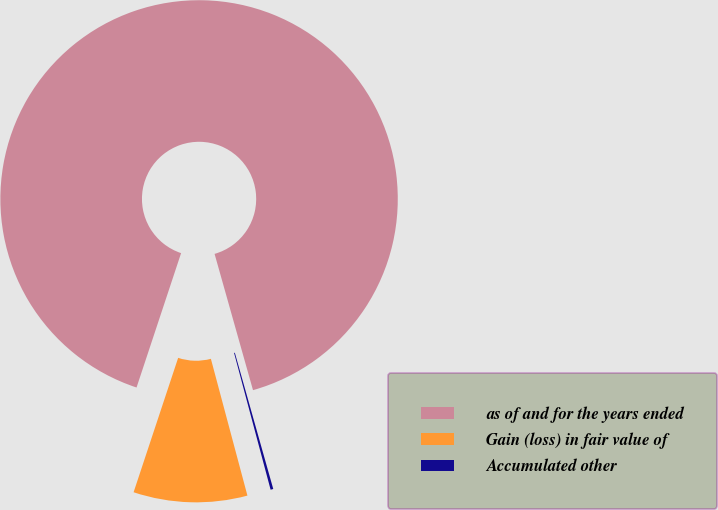Convert chart. <chart><loc_0><loc_0><loc_500><loc_500><pie_chart><fcel>as of and for the years ended<fcel>Gain (loss) in fair value of<fcel>Accumulated other<nl><fcel>90.52%<fcel>9.25%<fcel>0.22%<nl></chart> 